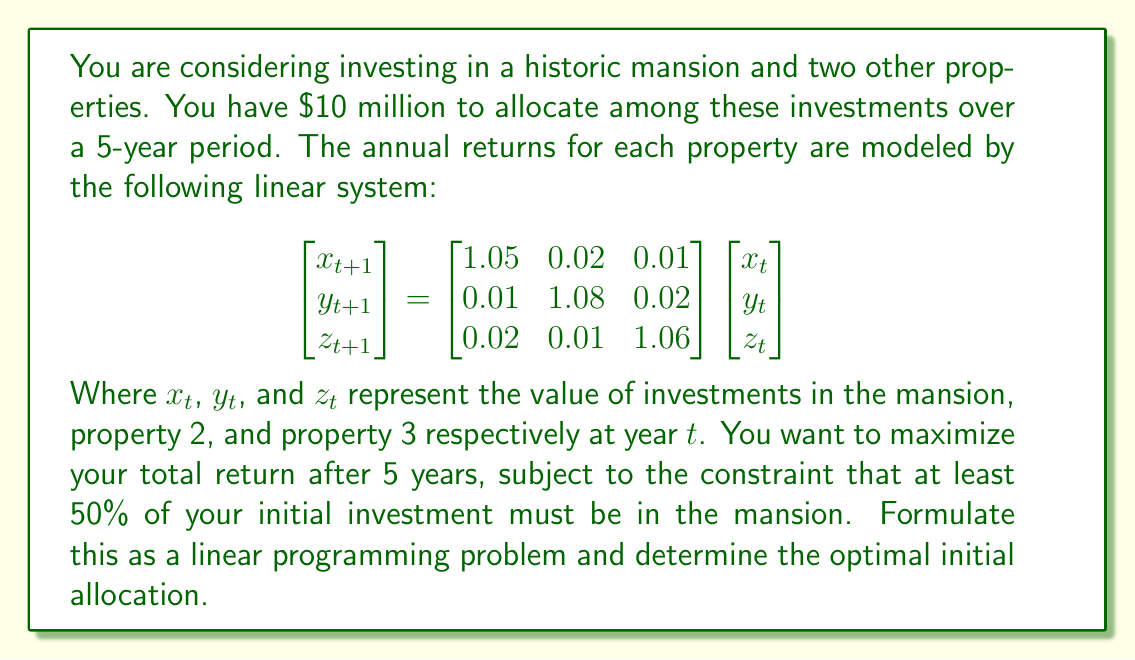Can you answer this question? To solve this problem, we'll follow these steps:

1) First, we need to express the final values after 5 years in terms of the initial investments. Let's call the initial investments $x_0$, $y_0$, and $z_0$.

2) The given system is a linear dynamical system. After 5 years, the values will be:

   $$\begin{bmatrix} x_5 \\ y_5 \\ z_5 \end{bmatrix} = \begin{bmatrix} 1.05 & 0.02 & 0.01 \\ 0.01 & 1.08 & 0.02 \\ 0.02 & 0.01 & 1.06 \end{bmatrix}^5 \begin{bmatrix} x_0 \\ y_0 \\ z_0 \end{bmatrix}$$

3) Let's call the 5th power of the matrix $A$. We can calculate this:

   $$A = \begin{bmatrix} 1.2762 & 0.1303 & 0.0935 \\ 0.0935 & 1.4692 & 0.1303 \\ 0.1303 & 0.0935 & 1.3366 \end{bmatrix}$$

4) Now, our objective is to maximize:

   $1.2762x_0 + 0.1303y_0 + 0.0935z_0 + 0.0935x_0 + 1.4692y_0 + 0.1303z_0 + 0.1303x_0 + 0.0935y_0 + 1.3366z_0$

   Which simplifies to:

   $1.5x_0 + 1.693y_0 + 1.5604z_0$

5) Our constraints are:
   - $x_0 + y_0 + z_0 = 10$ (total investment)
   - $x_0 \geq 5$ (at least 50% in the mansion)
   - $x_0, y_0, z_0 \geq 0$ (non-negative investments)

6) Therefore, our linear programming problem is:

   Maximize: $1.5x_0 + 1.693y_0 + 1.5604z_0$
   Subject to:
   $x_0 + y_0 + z_0 = 10$
   $x_0 \geq 5$
   $x_0, y_0, z_0 \geq 0$

7) Solving this linear programming problem (using a solver or graphical method) gives the optimal solution:
   $x_0 = 5, y_0 = 5, z_0 = 0$

This means you should invest $5 million in the mansion, $5 million in property 2, and nothing in property 3.
Answer: $x_0 = 5, y_0 = 5, z_0 = 0$ (in millions of dollars) 